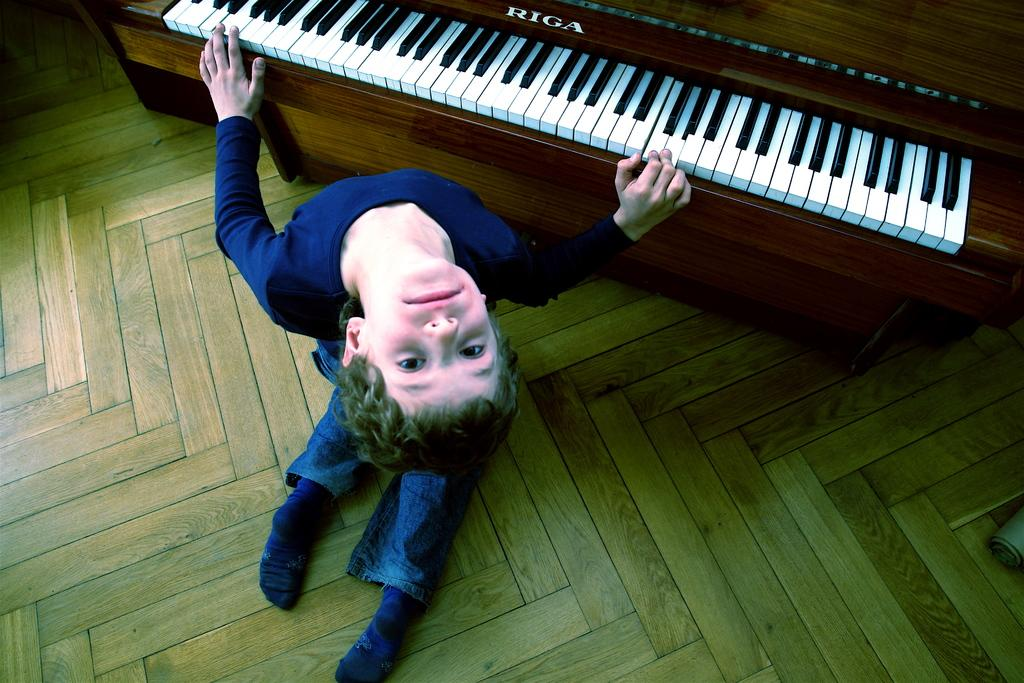Who is the main subject in the image? There is a boy in the image. What is the boy doing in the image? The boy is kneeling down on the floor and playing a piano. What can be seen on the piano? There are keys on the piano, and the text "Riga" is on the piano. What type of floor is visible in the image? There is a wooden floor in the image. Can you tell me how many scales are hanging on the wall in the image? There are no scales visible in the image; it features a boy playing a piano on a wooden floor. Is there a water source visible in the image? There is no water source visible in the image. 